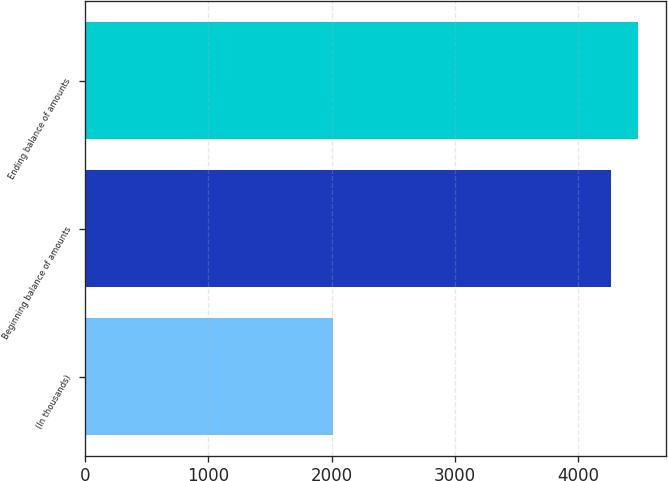Convert chart. <chart><loc_0><loc_0><loc_500><loc_500><bar_chart><fcel>(In thousands)<fcel>Beginning balance of amounts<fcel>Ending balance of amounts<nl><fcel>2013<fcel>4261<fcel>4485.8<nl></chart> 